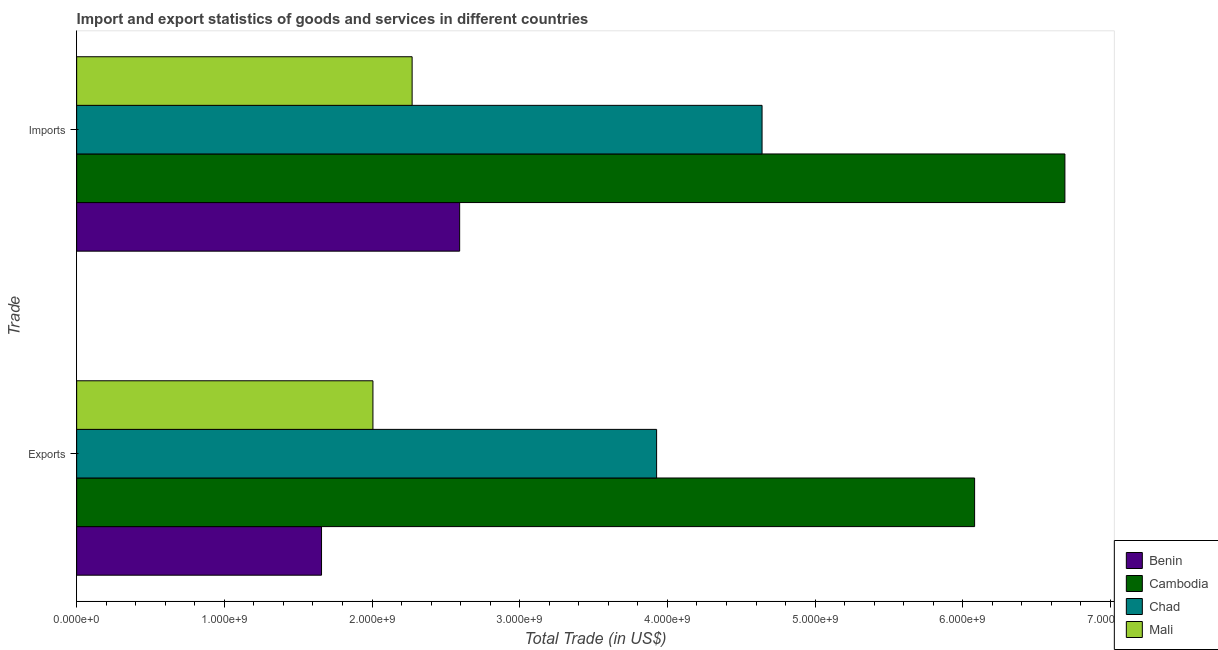How many different coloured bars are there?
Ensure brevity in your answer.  4. How many groups of bars are there?
Your answer should be very brief. 2. Are the number of bars on each tick of the Y-axis equal?
Offer a very short reply. Yes. How many bars are there on the 2nd tick from the top?
Offer a very short reply. 4. How many bars are there on the 2nd tick from the bottom?
Your answer should be compact. 4. What is the label of the 2nd group of bars from the top?
Offer a very short reply. Exports. What is the export of goods and services in Cambodia?
Ensure brevity in your answer.  6.08e+09. Across all countries, what is the maximum export of goods and services?
Offer a terse response. 6.08e+09. Across all countries, what is the minimum export of goods and services?
Keep it short and to the point. 1.66e+09. In which country was the export of goods and services maximum?
Provide a succinct answer. Cambodia. In which country was the imports of goods and services minimum?
Offer a terse response. Mali. What is the total export of goods and services in the graph?
Offer a terse response. 1.37e+1. What is the difference between the export of goods and services in Mali and that in Cambodia?
Your answer should be very brief. -4.07e+09. What is the difference between the export of goods and services in Benin and the imports of goods and services in Mali?
Provide a succinct answer. -6.13e+08. What is the average imports of goods and services per country?
Offer a terse response. 4.05e+09. What is the difference between the imports of goods and services and export of goods and services in Benin?
Make the answer very short. 9.35e+08. In how many countries, is the export of goods and services greater than 3600000000 US$?
Make the answer very short. 2. What is the ratio of the imports of goods and services in Chad to that in Mali?
Offer a very short reply. 2.04. In how many countries, is the export of goods and services greater than the average export of goods and services taken over all countries?
Make the answer very short. 2. What does the 1st bar from the top in Imports represents?
Offer a terse response. Mali. What does the 1st bar from the bottom in Imports represents?
Give a very brief answer. Benin. How many bars are there?
Make the answer very short. 8. Are all the bars in the graph horizontal?
Provide a succinct answer. Yes. How many countries are there in the graph?
Give a very brief answer. 4. What is the difference between two consecutive major ticks on the X-axis?
Make the answer very short. 1.00e+09. Are the values on the major ticks of X-axis written in scientific E-notation?
Provide a short and direct response. Yes. Does the graph contain any zero values?
Provide a short and direct response. No. Where does the legend appear in the graph?
Your answer should be compact. Bottom right. How many legend labels are there?
Provide a short and direct response. 4. What is the title of the graph?
Your answer should be compact. Import and export statistics of goods and services in different countries. Does "Comoros" appear as one of the legend labels in the graph?
Your answer should be very brief. No. What is the label or title of the X-axis?
Offer a very short reply. Total Trade (in US$). What is the label or title of the Y-axis?
Provide a succinct answer. Trade. What is the Total Trade (in US$) of Benin in Exports?
Provide a succinct answer. 1.66e+09. What is the Total Trade (in US$) in Cambodia in Exports?
Offer a very short reply. 6.08e+09. What is the Total Trade (in US$) in Chad in Exports?
Provide a short and direct response. 3.93e+09. What is the Total Trade (in US$) of Mali in Exports?
Provide a short and direct response. 2.01e+09. What is the Total Trade (in US$) of Benin in Imports?
Offer a very short reply. 2.59e+09. What is the Total Trade (in US$) in Cambodia in Imports?
Your answer should be compact. 6.69e+09. What is the Total Trade (in US$) in Chad in Imports?
Give a very brief answer. 4.64e+09. What is the Total Trade (in US$) of Mali in Imports?
Your answer should be very brief. 2.27e+09. Across all Trade, what is the maximum Total Trade (in US$) of Benin?
Give a very brief answer. 2.59e+09. Across all Trade, what is the maximum Total Trade (in US$) in Cambodia?
Provide a succinct answer. 6.69e+09. Across all Trade, what is the maximum Total Trade (in US$) in Chad?
Offer a terse response. 4.64e+09. Across all Trade, what is the maximum Total Trade (in US$) of Mali?
Provide a succinct answer. 2.27e+09. Across all Trade, what is the minimum Total Trade (in US$) of Benin?
Offer a terse response. 1.66e+09. Across all Trade, what is the minimum Total Trade (in US$) in Cambodia?
Provide a short and direct response. 6.08e+09. Across all Trade, what is the minimum Total Trade (in US$) in Chad?
Provide a succinct answer. 3.93e+09. Across all Trade, what is the minimum Total Trade (in US$) in Mali?
Provide a short and direct response. 2.01e+09. What is the total Total Trade (in US$) in Benin in the graph?
Offer a terse response. 4.25e+09. What is the total Total Trade (in US$) in Cambodia in the graph?
Offer a terse response. 1.28e+1. What is the total Total Trade (in US$) of Chad in the graph?
Ensure brevity in your answer.  8.57e+09. What is the total Total Trade (in US$) in Mali in the graph?
Give a very brief answer. 4.28e+09. What is the difference between the Total Trade (in US$) of Benin in Exports and that in Imports?
Ensure brevity in your answer.  -9.35e+08. What is the difference between the Total Trade (in US$) in Cambodia in Exports and that in Imports?
Ensure brevity in your answer.  -6.11e+08. What is the difference between the Total Trade (in US$) in Chad in Exports and that in Imports?
Keep it short and to the point. -7.14e+08. What is the difference between the Total Trade (in US$) in Mali in Exports and that in Imports?
Your response must be concise. -2.65e+08. What is the difference between the Total Trade (in US$) in Benin in Exports and the Total Trade (in US$) in Cambodia in Imports?
Provide a short and direct response. -5.03e+09. What is the difference between the Total Trade (in US$) of Benin in Exports and the Total Trade (in US$) of Chad in Imports?
Make the answer very short. -2.98e+09. What is the difference between the Total Trade (in US$) in Benin in Exports and the Total Trade (in US$) in Mali in Imports?
Provide a succinct answer. -6.13e+08. What is the difference between the Total Trade (in US$) of Cambodia in Exports and the Total Trade (in US$) of Chad in Imports?
Your response must be concise. 1.44e+09. What is the difference between the Total Trade (in US$) of Cambodia in Exports and the Total Trade (in US$) of Mali in Imports?
Give a very brief answer. 3.81e+09. What is the difference between the Total Trade (in US$) of Chad in Exports and the Total Trade (in US$) of Mali in Imports?
Provide a short and direct response. 1.66e+09. What is the average Total Trade (in US$) in Benin per Trade?
Offer a terse response. 2.13e+09. What is the average Total Trade (in US$) of Cambodia per Trade?
Provide a short and direct response. 6.39e+09. What is the average Total Trade (in US$) of Chad per Trade?
Your answer should be very brief. 4.28e+09. What is the average Total Trade (in US$) in Mali per Trade?
Provide a short and direct response. 2.14e+09. What is the difference between the Total Trade (in US$) of Benin and Total Trade (in US$) of Cambodia in Exports?
Give a very brief answer. -4.42e+09. What is the difference between the Total Trade (in US$) of Benin and Total Trade (in US$) of Chad in Exports?
Your answer should be very brief. -2.27e+09. What is the difference between the Total Trade (in US$) of Benin and Total Trade (in US$) of Mali in Exports?
Offer a terse response. -3.48e+08. What is the difference between the Total Trade (in US$) in Cambodia and Total Trade (in US$) in Chad in Exports?
Your answer should be compact. 2.15e+09. What is the difference between the Total Trade (in US$) of Cambodia and Total Trade (in US$) of Mali in Exports?
Provide a short and direct response. 4.07e+09. What is the difference between the Total Trade (in US$) in Chad and Total Trade (in US$) in Mali in Exports?
Give a very brief answer. 1.92e+09. What is the difference between the Total Trade (in US$) of Benin and Total Trade (in US$) of Cambodia in Imports?
Offer a terse response. -4.10e+09. What is the difference between the Total Trade (in US$) in Benin and Total Trade (in US$) in Chad in Imports?
Your answer should be compact. -2.05e+09. What is the difference between the Total Trade (in US$) of Benin and Total Trade (in US$) of Mali in Imports?
Provide a short and direct response. 3.22e+08. What is the difference between the Total Trade (in US$) of Cambodia and Total Trade (in US$) of Chad in Imports?
Give a very brief answer. 2.05e+09. What is the difference between the Total Trade (in US$) of Cambodia and Total Trade (in US$) of Mali in Imports?
Make the answer very short. 4.42e+09. What is the difference between the Total Trade (in US$) in Chad and Total Trade (in US$) in Mali in Imports?
Keep it short and to the point. 2.37e+09. What is the ratio of the Total Trade (in US$) in Benin in Exports to that in Imports?
Offer a terse response. 0.64. What is the ratio of the Total Trade (in US$) in Cambodia in Exports to that in Imports?
Offer a very short reply. 0.91. What is the ratio of the Total Trade (in US$) in Chad in Exports to that in Imports?
Offer a very short reply. 0.85. What is the ratio of the Total Trade (in US$) in Mali in Exports to that in Imports?
Offer a terse response. 0.88. What is the difference between the highest and the second highest Total Trade (in US$) of Benin?
Offer a terse response. 9.35e+08. What is the difference between the highest and the second highest Total Trade (in US$) in Cambodia?
Keep it short and to the point. 6.11e+08. What is the difference between the highest and the second highest Total Trade (in US$) in Chad?
Your response must be concise. 7.14e+08. What is the difference between the highest and the second highest Total Trade (in US$) in Mali?
Offer a terse response. 2.65e+08. What is the difference between the highest and the lowest Total Trade (in US$) in Benin?
Your response must be concise. 9.35e+08. What is the difference between the highest and the lowest Total Trade (in US$) of Cambodia?
Provide a short and direct response. 6.11e+08. What is the difference between the highest and the lowest Total Trade (in US$) in Chad?
Your answer should be very brief. 7.14e+08. What is the difference between the highest and the lowest Total Trade (in US$) in Mali?
Keep it short and to the point. 2.65e+08. 